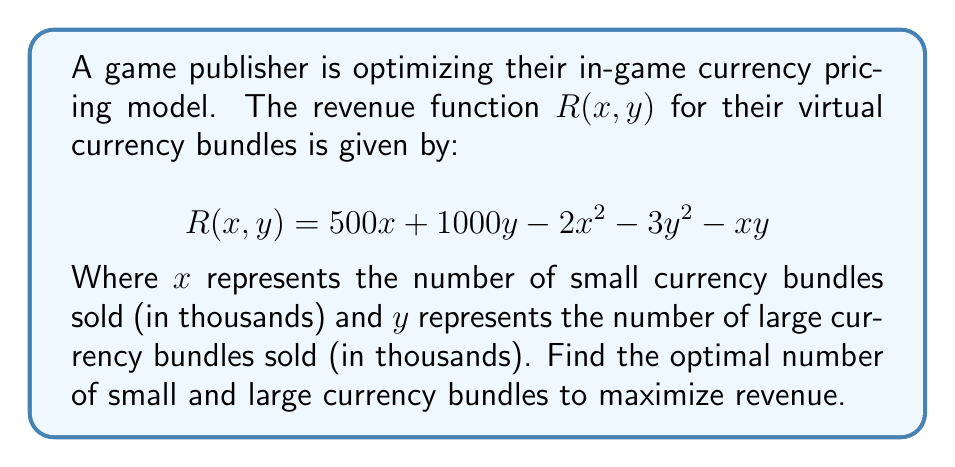Can you solve this math problem? To find the optimal number of small and large currency bundles that maximize revenue, we need to find the critical points of the revenue function $R(x, y)$ using partial derivatives.

1. Calculate the partial derivatives:

   $$\frac{\partial R}{\partial x} = 500 - 4x - y$$
   $$\frac{\partial R}{\partial y} = 1000 - 6y - x$$

2. Set both partial derivatives to zero to find the critical points:

   $$\frac{\partial R}{\partial x} = 500 - 4x - y = 0$$
   $$\frac{\partial R}{\partial y} = 1000 - 6y - x = 0$$

3. Solve the system of equations:
   From the first equation:
   $$y = 500 - 4x$$

   Substitute this into the second equation:
   $$1000 - 6(500 - 4x) - x = 0$$
   $$1000 - 3000 + 24x - x = 0$$
   $$23x = 2000$$
   $$x = \frac{2000}{23} \approx 86.96$$

   Substitute this x-value back into the equation for y:
   $$y = 500 - 4(\frac{2000}{23}) \approx 152.17$$

4. Verify that this critical point is a maximum by checking the second partial derivatives:

   $$\frac{\partial^2 R}{\partial x^2} = -4$$
   $$\frac{\partial^2 R}{\partial y^2} = -6$$
   $$\frac{\partial^2 R}{\partial x \partial y} = -1$$

   The Hessian matrix is:
   $$H = \begin{bmatrix} -4 & -1 \\ -1 & -6 \end{bmatrix}$$

   The determinant of H is positive (23 > 0), and $\frac{\partial^2 R}{\partial x^2}$ is negative, confirming that this critical point is a maximum.

5. Round the results to the nearest whole number, as fractional bundles cannot be sold.
Answer: The optimal number of small currency bundles to sell is approximately 87,000 ($x \approx 87$), and the optimal number of large currency bundles to sell is approximately 152,000 ($y \approx 152$) to maximize revenue. 